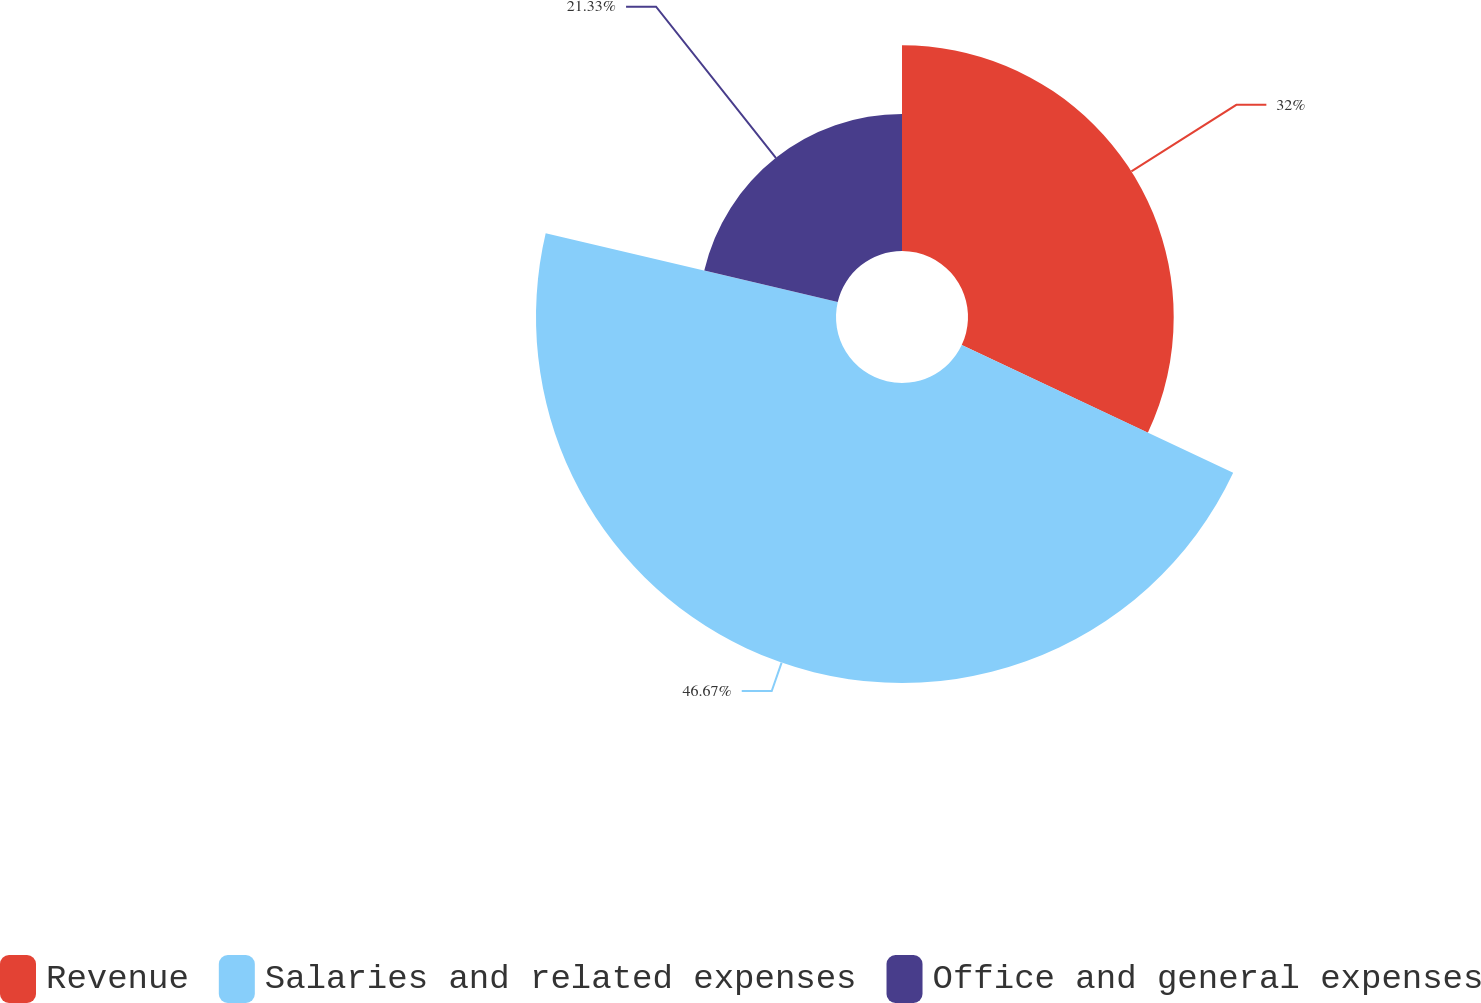Convert chart to OTSL. <chart><loc_0><loc_0><loc_500><loc_500><pie_chart><fcel>Revenue<fcel>Salaries and related expenses<fcel>Office and general expenses<nl><fcel>32.0%<fcel>46.67%<fcel>21.33%<nl></chart> 